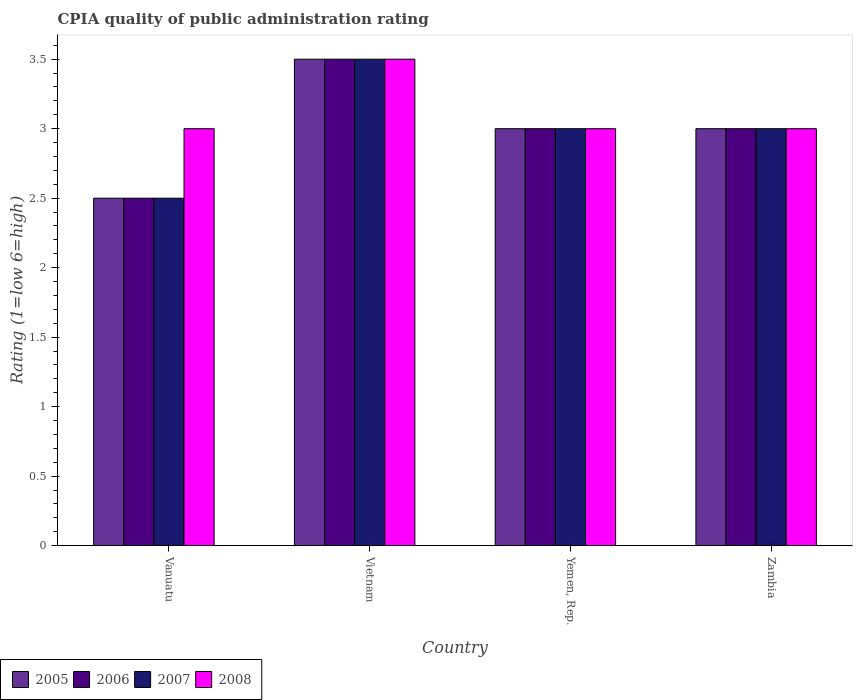Are the number of bars on each tick of the X-axis equal?
Give a very brief answer. Yes. How many bars are there on the 4th tick from the right?
Provide a succinct answer. 4. What is the label of the 1st group of bars from the left?
Offer a terse response. Vanuatu. In which country was the CPIA rating in 2006 maximum?
Offer a very short reply. Vietnam. In which country was the CPIA rating in 2008 minimum?
Provide a succinct answer. Vanuatu. What is the total CPIA rating in 2006 in the graph?
Your answer should be very brief. 12. What is the difference between the CPIA rating in 2007 in Vietnam and that in Yemen, Rep.?
Your answer should be compact. 0.5. What is the average CPIA rating in 2006 per country?
Offer a terse response. 3. What is the difference between the CPIA rating of/in 2006 and CPIA rating of/in 2005 in Vanuatu?
Provide a short and direct response. 0. Is the difference between the CPIA rating in 2006 in Vanuatu and Zambia greater than the difference between the CPIA rating in 2005 in Vanuatu and Zambia?
Provide a succinct answer. No. What is the difference between the highest and the second highest CPIA rating in 2006?
Your response must be concise. -0.5. In how many countries, is the CPIA rating in 2008 greater than the average CPIA rating in 2008 taken over all countries?
Your answer should be compact. 1. Is the sum of the CPIA rating in 2005 in Vanuatu and Yemen, Rep. greater than the maximum CPIA rating in 2006 across all countries?
Your response must be concise. Yes. What does the 2nd bar from the right in Vanuatu represents?
Provide a succinct answer. 2007. Is it the case that in every country, the sum of the CPIA rating in 2008 and CPIA rating in 2006 is greater than the CPIA rating in 2005?
Give a very brief answer. Yes. How many bars are there?
Keep it short and to the point. 16. What is the difference between two consecutive major ticks on the Y-axis?
Provide a short and direct response. 0.5. Are the values on the major ticks of Y-axis written in scientific E-notation?
Your answer should be very brief. No. Does the graph contain grids?
Your response must be concise. No. How many legend labels are there?
Your response must be concise. 4. How are the legend labels stacked?
Your answer should be compact. Horizontal. What is the title of the graph?
Give a very brief answer. CPIA quality of public administration rating. Does "1970" appear as one of the legend labels in the graph?
Your response must be concise. No. What is the label or title of the Y-axis?
Keep it short and to the point. Rating (1=low 6=high). What is the Rating (1=low 6=high) in 2005 in Vanuatu?
Offer a terse response. 2.5. What is the Rating (1=low 6=high) in 2006 in Vietnam?
Make the answer very short. 3.5. What is the Rating (1=low 6=high) of 2005 in Yemen, Rep.?
Your response must be concise. 3. What is the Rating (1=low 6=high) in 2008 in Yemen, Rep.?
Your answer should be very brief. 3. What is the Rating (1=low 6=high) of 2005 in Zambia?
Your response must be concise. 3. What is the Rating (1=low 6=high) in 2006 in Zambia?
Keep it short and to the point. 3. Across all countries, what is the maximum Rating (1=low 6=high) in 2005?
Keep it short and to the point. 3.5. Across all countries, what is the maximum Rating (1=low 6=high) of 2007?
Offer a very short reply. 3.5. Across all countries, what is the minimum Rating (1=low 6=high) of 2005?
Provide a succinct answer. 2.5. Across all countries, what is the minimum Rating (1=low 6=high) in 2007?
Your answer should be very brief. 2.5. What is the total Rating (1=low 6=high) of 2005 in the graph?
Provide a succinct answer. 12. What is the total Rating (1=low 6=high) of 2007 in the graph?
Give a very brief answer. 12. What is the total Rating (1=low 6=high) of 2008 in the graph?
Keep it short and to the point. 12.5. What is the difference between the Rating (1=low 6=high) in 2005 in Vanuatu and that in Vietnam?
Make the answer very short. -1. What is the difference between the Rating (1=low 6=high) of 2005 in Vanuatu and that in Yemen, Rep.?
Provide a succinct answer. -0.5. What is the difference between the Rating (1=low 6=high) in 2007 in Vanuatu and that in Yemen, Rep.?
Your answer should be very brief. -0.5. What is the difference between the Rating (1=low 6=high) of 2008 in Vanuatu and that in Yemen, Rep.?
Give a very brief answer. 0. What is the difference between the Rating (1=low 6=high) in 2006 in Vanuatu and that in Zambia?
Give a very brief answer. -0.5. What is the difference between the Rating (1=low 6=high) in 2007 in Vanuatu and that in Zambia?
Your response must be concise. -0.5. What is the difference between the Rating (1=low 6=high) of 2005 in Vietnam and that in Yemen, Rep.?
Your answer should be compact. 0.5. What is the difference between the Rating (1=low 6=high) of 2006 in Vietnam and that in Yemen, Rep.?
Provide a succinct answer. 0.5. What is the difference between the Rating (1=low 6=high) of 2007 in Vietnam and that in Zambia?
Make the answer very short. 0.5. What is the difference between the Rating (1=low 6=high) of 2008 in Vietnam and that in Zambia?
Your response must be concise. 0.5. What is the difference between the Rating (1=low 6=high) in 2005 in Yemen, Rep. and that in Zambia?
Provide a succinct answer. 0. What is the difference between the Rating (1=low 6=high) in 2006 in Yemen, Rep. and that in Zambia?
Give a very brief answer. 0. What is the difference between the Rating (1=low 6=high) in 2007 in Yemen, Rep. and that in Zambia?
Your answer should be very brief. 0. What is the difference between the Rating (1=low 6=high) in 2008 in Yemen, Rep. and that in Zambia?
Provide a succinct answer. 0. What is the difference between the Rating (1=low 6=high) in 2005 in Vanuatu and the Rating (1=low 6=high) in 2006 in Vietnam?
Keep it short and to the point. -1. What is the difference between the Rating (1=low 6=high) in 2005 in Vanuatu and the Rating (1=low 6=high) in 2007 in Vietnam?
Make the answer very short. -1. What is the difference between the Rating (1=low 6=high) of 2006 in Vanuatu and the Rating (1=low 6=high) of 2008 in Vietnam?
Ensure brevity in your answer.  -1. What is the difference between the Rating (1=low 6=high) in 2007 in Vanuatu and the Rating (1=low 6=high) in 2008 in Vietnam?
Offer a very short reply. -1. What is the difference between the Rating (1=low 6=high) of 2005 in Vanuatu and the Rating (1=low 6=high) of 2008 in Yemen, Rep.?
Offer a terse response. -0.5. What is the difference between the Rating (1=low 6=high) in 2006 in Vanuatu and the Rating (1=low 6=high) in 2008 in Yemen, Rep.?
Ensure brevity in your answer.  -0.5. What is the difference between the Rating (1=low 6=high) of 2007 in Vanuatu and the Rating (1=low 6=high) of 2008 in Yemen, Rep.?
Your answer should be compact. -0.5. What is the difference between the Rating (1=low 6=high) of 2005 in Vanuatu and the Rating (1=low 6=high) of 2006 in Zambia?
Your answer should be compact. -0.5. What is the difference between the Rating (1=low 6=high) in 2005 in Vanuatu and the Rating (1=low 6=high) in 2007 in Zambia?
Ensure brevity in your answer.  -0.5. What is the difference between the Rating (1=low 6=high) in 2005 in Vanuatu and the Rating (1=low 6=high) in 2008 in Zambia?
Your answer should be very brief. -0.5. What is the difference between the Rating (1=low 6=high) in 2006 in Vanuatu and the Rating (1=low 6=high) in 2007 in Zambia?
Provide a succinct answer. -0.5. What is the difference between the Rating (1=low 6=high) of 2005 in Vietnam and the Rating (1=low 6=high) of 2007 in Yemen, Rep.?
Your answer should be compact. 0.5. What is the difference between the Rating (1=low 6=high) of 2005 in Vietnam and the Rating (1=low 6=high) of 2008 in Yemen, Rep.?
Your answer should be very brief. 0.5. What is the difference between the Rating (1=low 6=high) in 2006 in Vietnam and the Rating (1=low 6=high) in 2007 in Yemen, Rep.?
Your answer should be very brief. 0.5. What is the difference between the Rating (1=low 6=high) of 2006 in Vietnam and the Rating (1=low 6=high) of 2008 in Yemen, Rep.?
Ensure brevity in your answer.  0.5. What is the difference between the Rating (1=low 6=high) in 2005 in Vietnam and the Rating (1=low 6=high) in 2006 in Zambia?
Keep it short and to the point. 0.5. What is the difference between the Rating (1=low 6=high) of 2005 in Yemen, Rep. and the Rating (1=low 6=high) of 2006 in Zambia?
Keep it short and to the point. 0. What is the difference between the Rating (1=low 6=high) of 2005 in Yemen, Rep. and the Rating (1=low 6=high) of 2007 in Zambia?
Give a very brief answer. 0. What is the difference between the Rating (1=low 6=high) in 2007 in Yemen, Rep. and the Rating (1=low 6=high) in 2008 in Zambia?
Ensure brevity in your answer.  0. What is the average Rating (1=low 6=high) of 2005 per country?
Offer a terse response. 3. What is the average Rating (1=low 6=high) of 2006 per country?
Give a very brief answer. 3. What is the average Rating (1=low 6=high) of 2007 per country?
Make the answer very short. 3. What is the average Rating (1=low 6=high) of 2008 per country?
Make the answer very short. 3.12. What is the difference between the Rating (1=low 6=high) of 2005 and Rating (1=low 6=high) of 2007 in Vanuatu?
Ensure brevity in your answer.  0. What is the difference between the Rating (1=low 6=high) in 2005 and Rating (1=low 6=high) in 2008 in Vanuatu?
Give a very brief answer. -0.5. What is the difference between the Rating (1=low 6=high) in 2006 and Rating (1=low 6=high) in 2007 in Vanuatu?
Your answer should be very brief. 0. What is the difference between the Rating (1=low 6=high) in 2006 and Rating (1=low 6=high) in 2008 in Vanuatu?
Make the answer very short. -0.5. What is the difference between the Rating (1=low 6=high) of 2005 and Rating (1=low 6=high) of 2007 in Vietnam?
Offer a very short reply. 0. What is the difference between the Rating (1=low 6=high) of 2005 and Rating (1=low 6=high) of 2008 in Vietnam?
Provide a succinct answer. 0. What is the difference between the Rating (1=low 6=high) of 2007 and Rating (1=low 6=high) of 2008 in Vietnam?
Offer a terse response. 0. What is the difference between the Rating (1=low 6=high) in 2005 and Rating (1=low 6=high) in 2006 in Yemen, Rep.?
Make the answer very short. 0. What is the difference between the Rating (1=low 6=high) in 2005 and Rating (1=low 6=high) in 2008 in Yemen, Rep.?
Your answer should be compact. 0. What is the difference between the Rating (1=low 6=high) of 2007 and Rating (1=low 6=high) of 2008 in Yemen, Rep.?
Provide a short and direct response. 0. What is the difference between the Rating (1=low 6=high) of 2005 and Rating (1=low 6=high) of 2007 in Zambia?
Offer a terse response. 0. What is the difference between the Rating (1=low 6=high) of 2005 and Rating (1=low 6=high) of 2008 in Zambia?
Keep it short and to the point. 0. What is the ratio of the Rating (1=low 6=high) of 2006 in Vanuatu to that in Vietnam?
Provide a succinct answer. 0.71. What is the ratio of the Rating (1=low 6=high) of 2005 in Vanuatu to that in Yemen, Rep.?
Your response must be concise. 0.83. What is the ratio of the Rating (1=low 6=high) of 2006 in Vanuatu to that in Yemen, Rep.?
Your response must be concise. 0.83. What is the ratio of the Rating (1=low 6=high) of 2007 in Vanuatu to that in Yemen, Rep.?
Give a very brief answer. 0.83. What is the ratio of the Rating (1=low 6=high) in 2008 in Vanuatu to that in Yemen, Rep.?
Your response must be concise. 1. What is the ratio of the Rating (1=low 6=high) in 2006 in Vanuatu to that in Zambia?
Offer a terse response. 0.83. What is the ratio of the Rating (1=low 6=high) of 2007 in Vanuatu to that in Zambia?
Provide a short and direct response. 0.83. What is the ratio of the Rating (1=low 6=high) of 2006 in Vietnam to that in Yemen, Rep.?
Your answer should be compact. 1.17. What is the ratio of the Rating (1=low 6=high) in 2007 in Vietnam to that in Yemen, Rep.?
Your answer should be very brief. 1.17. What is the ratio of the Rating (1=low 6=high) in 2005 in Vietnam to that in Zambia?
Provide a short and direct response. 1.17. What is the ratio of the Rating (1=low 6=high) in 2006 in Vietnam to that in Zambia?
Ensure brevity in your answer.  1.17. What is the ratio of the Rating (1=low 6=high) in 2007 in Yemen, Rep. to that in Zambia?
Give a very brief answer. 1. What is the ratio of the Rating (1=low 6=high) of 2008 in Yemen, Rep. to that in Zambia?
Provide a short and direct response. 1. What is the difference between the highest and the second highest Rating (1=low 6=high) of 2005?
Offer a very short reply. 0.5. What is the difference between the highest and the second highest Rating (1=low 6=high) in 2008?
Provide a succinct answer. 0.5. What is the difference between the highest and the lowest Rating (1=low 6=high) of 2005?
Provide a short and direct response. 1. 